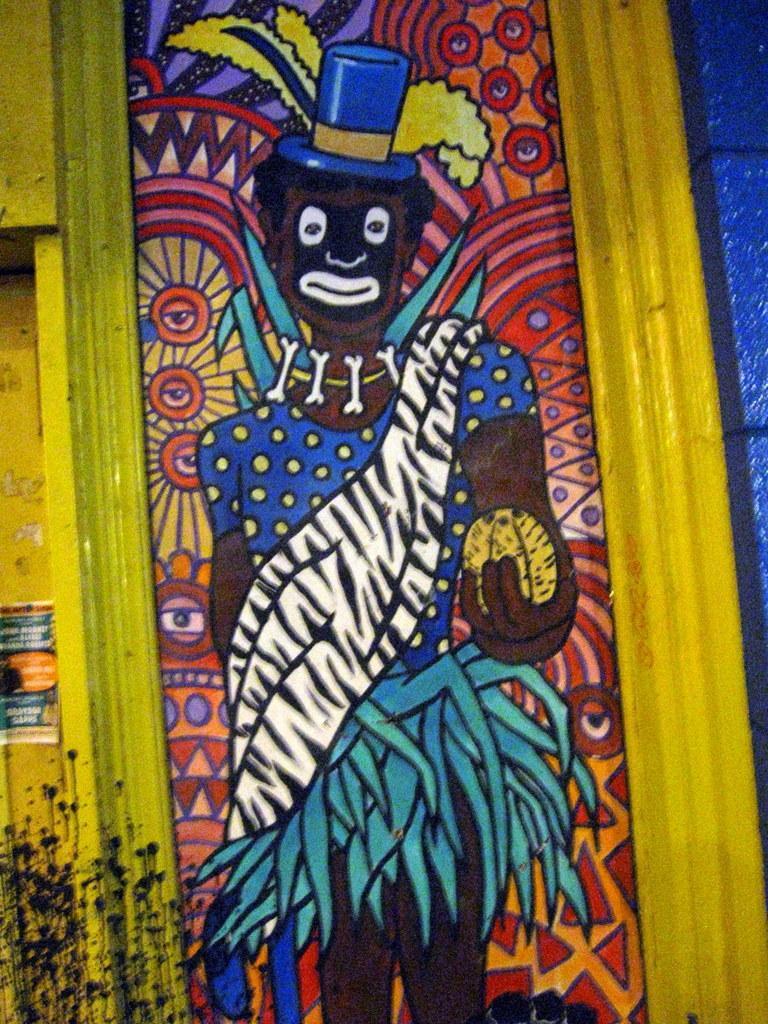Please provide a concise description of this image. In the middle of the image there is a painting on the wall. There is a painting of a person with different designs on it. And to the border of the wall there is yellow color. And to the right top corner of the image there is a blue color to the wall. 